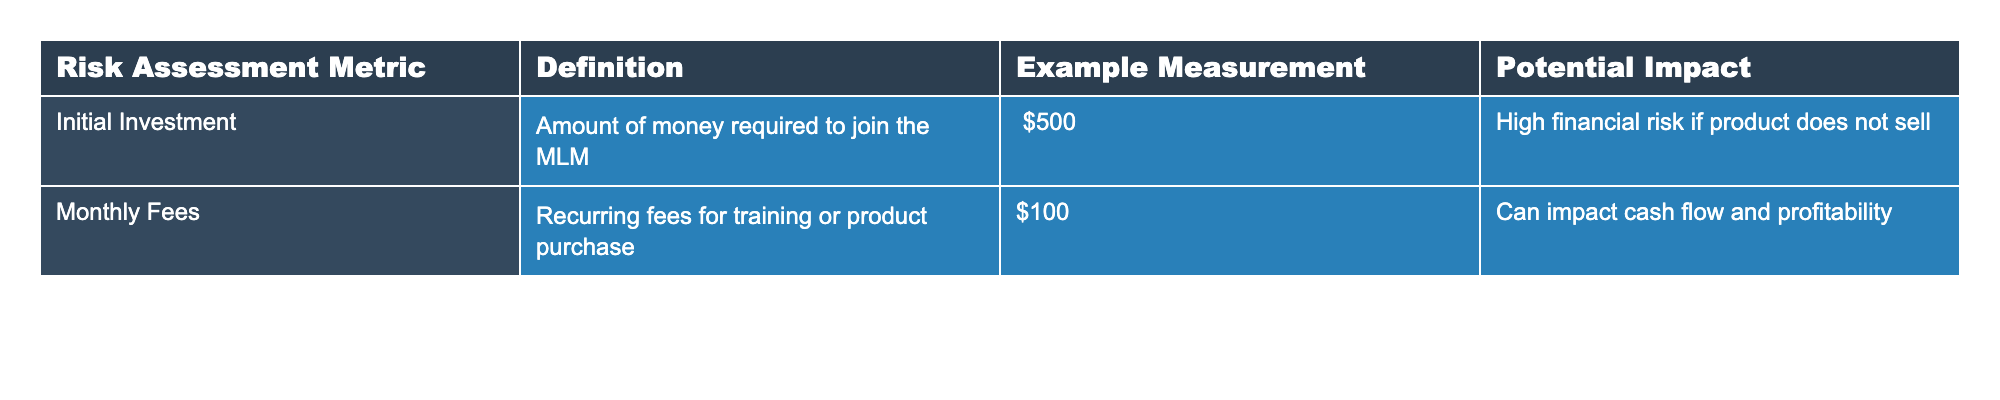What is the initial investment required to join the MLM? The initial investment is listed directly in the table under the Initial Investment metric, which shows an amount of $500.
Answer: $500 What are the example measurements for monthly fees? The table provides an example measurement for monthly fees of $100, which is also specified under the Monthly Fees metric.
Answer: $100 Is the potential impact of the initial investment categorized as high risk? According to the table, the potential impact of the initial investment is described as "High financial risk if product does not sell", indicating a high risk level.
Answer: Yes What is the total combined initial investment and monthly fees? To find the total, add the initial investment of $500 to the monthly fees of $100. This gives a total of $500 + $100 = $600.
Answer: $600 If someone incurs monthly fees for six months, what would that amount total? Monthly fees are $100, so over six months, the total would be 6 * $100 = $600.
Answer: $600 What is the difference in potential impact between the initial investment and monthly fees? The initial investment has a potential impact described as "High financial risk", while the monthly fees do not specify a risk category. The difference indicates that the initial investment carries a higher financial risk compared to the monthly fees.
Answer: The initial investment has higher risk Considering the risk definitions, which metric poses a greater financial risk? The table states that the initial investment is a high financial risk if the product does not sell, indicating that it poses a greater risk compared to the monthly fees, which are recurring but not marked as high risk.
Answer: Initial investment poses greater risk 